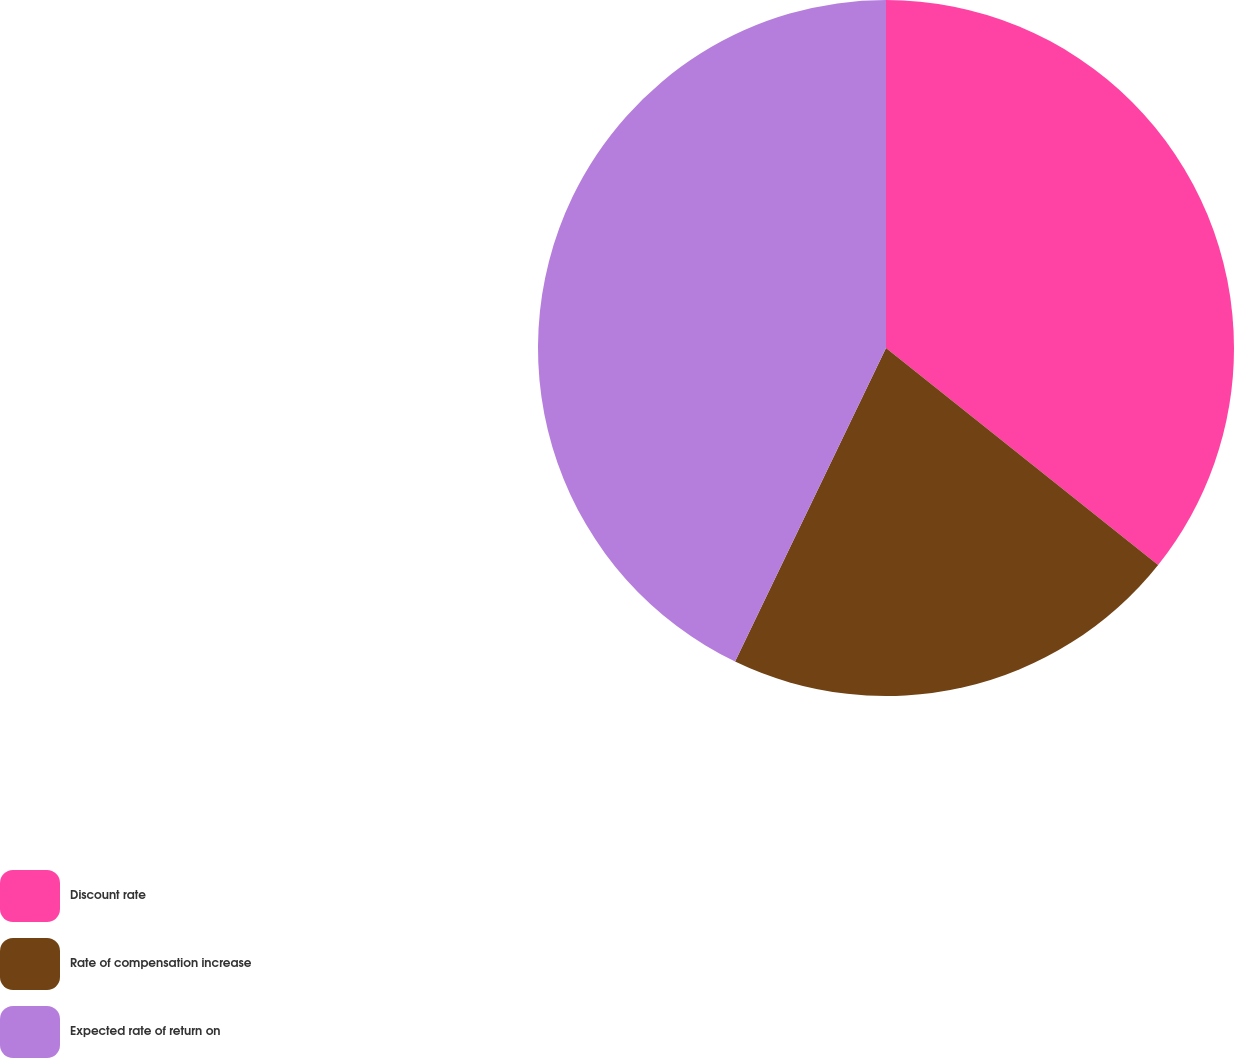Convert chart to OTSL. <chart><loc_0><loc_0><loc_500><loc_500><pie_chart><fcel>Discount rate<fcel>Rate of compensation increase<fcel>Expected rate of return on<nl><fcel>35.71%<fcel>21.43%<fcel>42.86%<nl></chart> 